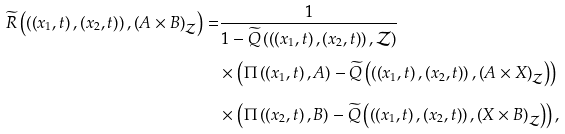<formula> <loc_0><loc_0><loc_500><loc_500>\widetilde { R } \left ( \left ( \left ( x _ { 1 } , t \right ) , \left ( x _ { 2 } , t \right ) \right ) , \left ( A \times B \right ) _ { \mathcal { Z } } \right ) = & \frac { 1 } { 1 - \widetilde { Q } \left ( \left ( \left ( x _ { 1 } , t \right ) , \left ( x _ { 2 } , t \right ) \right ) , \mathcal { Z } \right ) } \\ & \times \left ( \Pi \left ( \left ( x _ { 1 } , t \right ) , A \right ) - \widetilde { Q } \left ( \left ( \left ( x _ { 1 } , t \right ) , \left ( x _ { 2 } , t \right ) \right ) , \left ( A \times X \right ) _ { \mathcal { Z } } \right ) \right ) \\ & \times \left ( \Pi \left ( \left ( x _ { 2 } , t \right ) , B \right ) - \widetilde { Q } \left ( \left ( \left ( x _ { 1 } , t \right ) , \left ( x _ { 2 } , t \right ) \right ) , \left ( X \times B \right ) _ { \mathcal { Z } } \right ) \right ) ,</formula> 